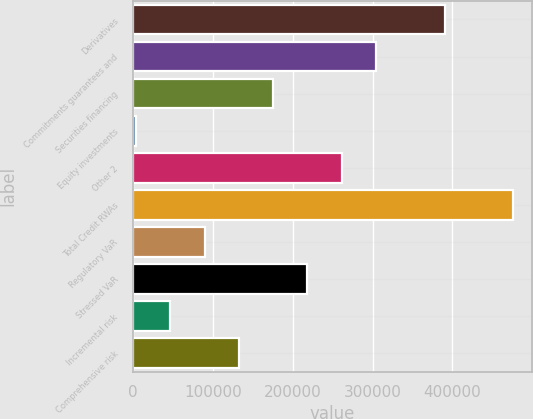Convert chart. <chart><loc_0><loc_0><loc_500><loc_500><bar_chart><fcel>Derivatives<fcel>Commitments guarantees and<fcel>Securities financing<fcel>Equity investments<fcel>Other 2<fcel>Total Credit RWAs<fcel>Regulatory VaR<fcel>Stressed VaR<fcel>Incremental risk<fcel>Comprehensive risk<nl><fcel>390271<fcel>304360<fcel>175494<fcel>3673<fcel>261405<fcel>476181<fcel>89583.6<fcel>218450<fcel>46628.3<fcel>132539<nl></chart> 